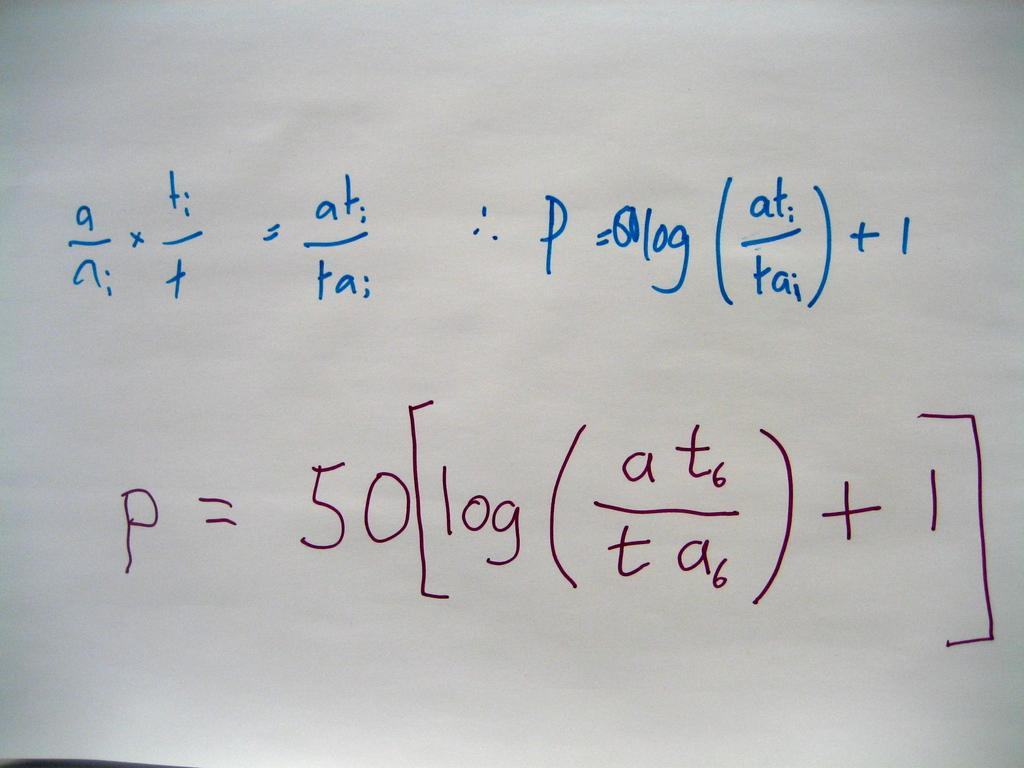<image>
Write a terse but informative summary of the picture. Mathematical problem drawn on a white paper that has log as part of the equation. 